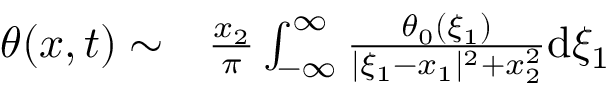<formula> <loc_0><loc_0><loc_500><loc_500>\begin{array} { r l } { \theta ( x , t ) \sim } & \frac { x _ { 2 } } { \pi } \int _ { - \infty } ^ { \infty } \frac { \theta _ { 0 } ( \xi _ { 1 } ) } { | \xi _ { 1 } - x _ { 1 } | ^ { 2 } + x _ { 2 } ^ { 2 } } d \xi _ { 1 } } \end{array}</formula> 